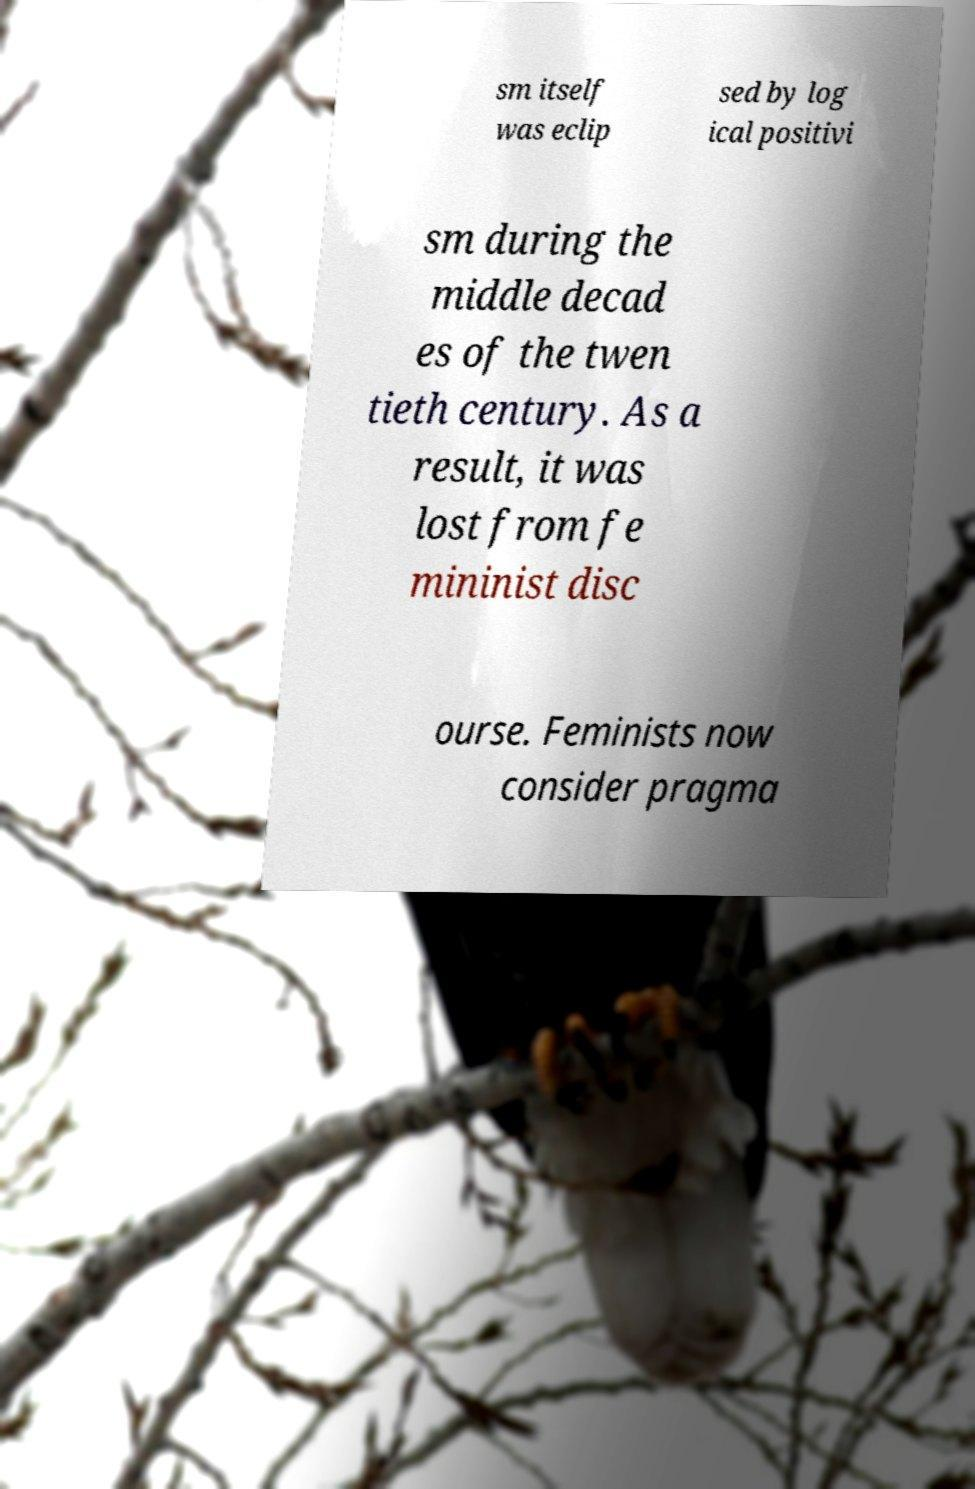What messages or text are displayed in this image? I need them in a readable, typed format. sm itself was eclip sed by log ical positivi sm during the middle decad es of the twen tieth century. As a result, it was lost from fe mininist disc ourse. Feminists now consider pragma 